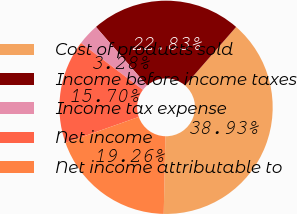<chart> <loc_0><loc_0><loc_500><loc_500><pie_chart><fcel>Cost of products sold<fcel>Income before income taxes<fcel>Income tax expense<fcel>Net income<fcel>Net income attributable to<nl><fcel>38.93%<fcel>22.83%<fcel>3.28%<fcel>15.7%<fcel>19.26%<nl></chart> 